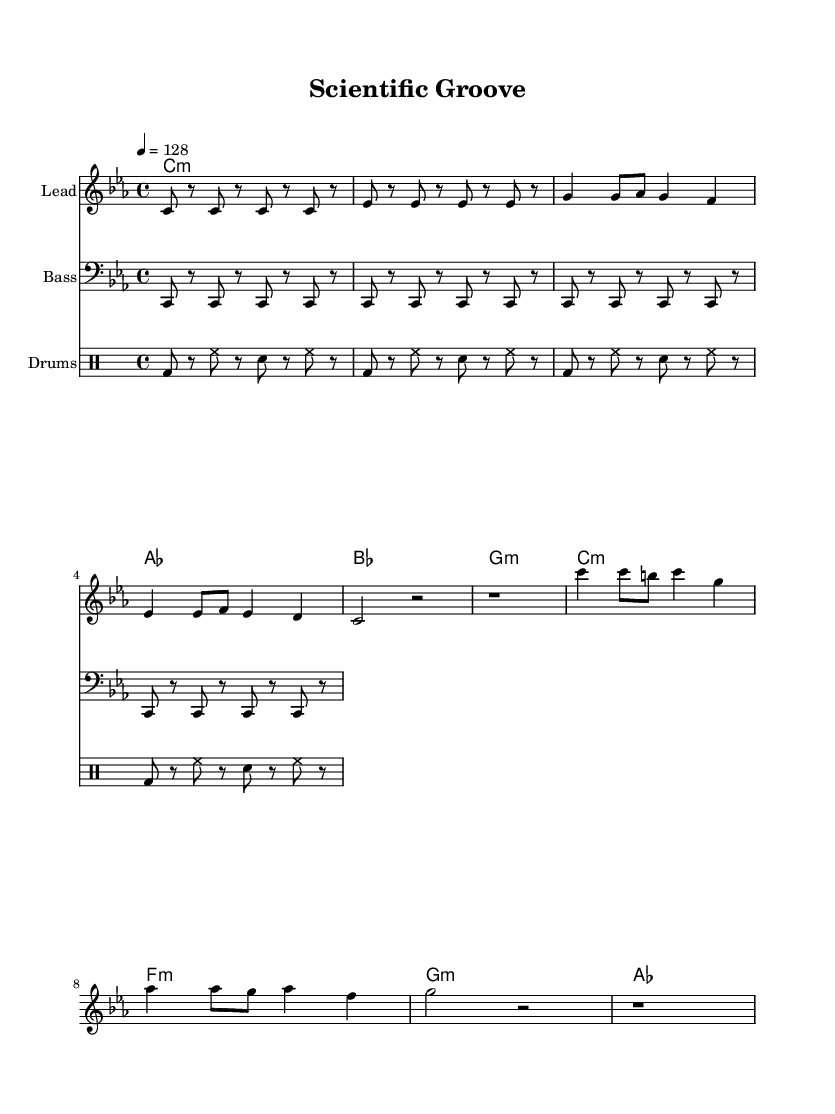What is the key signature of this music? The key signature is C minor, which has three flats (B, E, and A). This is evident from the key signature indicated at the beginning of the score, where there are three flat symbols shown.
Answer: C minor What is the time signature of this music? The time signature is 4/4, which means there are four beats per measure and a quarter note gets one beat. This is indicated at the beginning of the score where "4/4" is marked.
Answer: 4/4 What is the tempo marking for this piece? The tempo marking indicates a speed of 128 beats per minute (bpm). This is stated in the score with "4 = 128," meaning a quarter note is played at 128 bpm.
Answer: 128 How many measures are in the verse section? The verse section contains four measures. This can be counted directly within the score, where the corresponding notes and rests are organized into four distinct segments.
Answer: 4 What is the primary theme of the lyrics? The primary theme of the lyrics focuses on the scientific method and experiment documentation. This is evident from the lines that mention hypotheses, observation, and documentation, which are key aspects of scientific work.
Answer: Scientific method How many different drum sounds are used in the drum patterns? The drum patterns use three different sounds: bass drum (bd), hi-hat (hh), and snare (sn). These can be identified from the notational symbols in the drum staff section of the sheet music.
Answer: Three What type of song structure is evident in this piece? This piece follows a verse-chorus structure, which can be deduced from the arrangement of the sections in the lyrics and melody. The lyrics are divided into a verse and a chorus, indicating a typical structure in dance music.
Answer: Verse-chorus 